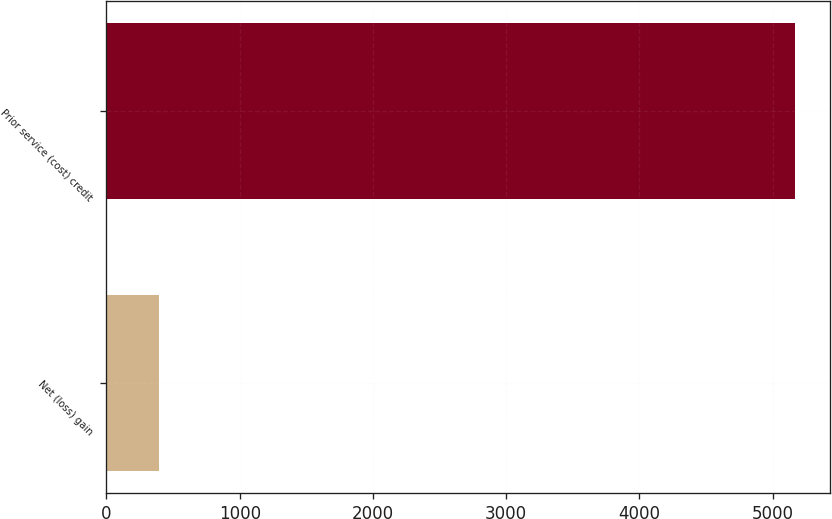Convert chart to OTSL. <chart><loc_0><loc_0><loc_500><loc_500><bar_chart><fcel>Net (loss) gain<fcel>Prior service (cost) credit<nl><fcel>394<fcel>5169<nl></chart> 